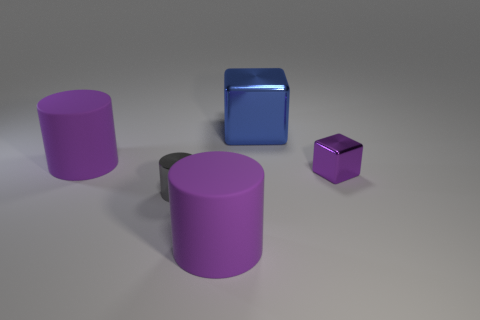Is the size of the blue metal cube the same as the metallic thing that is to the left of the big metallic cube? no 